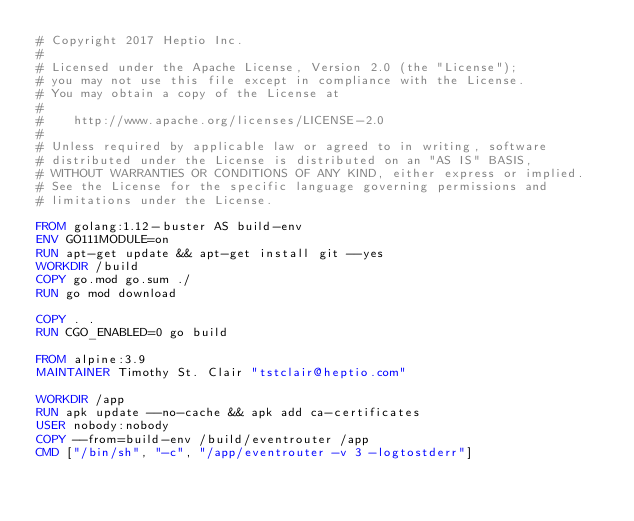<code> <loc_0><loc_0><loc_500><loc_500><_Dockerfile_># Copyright 2017 Heptio Inc.
#
# Licensed under the Apache License, Version 2.0 (the "License");
# you may not use this file except in compliance with the License.
# You may obtain a copy of the License at
#
#    http://www.apache.org/licenses/LICENSE-2.0
#
# Unless required by applicable law or agreed to in writing, software
# distributed under the License is distributed on an "AS IS" BASIS,
# WITHOUT WARRANTIES OR CONDITIONS OF ANY KIND, either express or implied.
# See the License for the specific language governing permissions and
# limitations under the License.

FROM golang:1.12-buster AS build-env
ENV GO111MODULE=on
RUN apt-get update && apt-get install git --yes
WORKDIR /build
COPY go.mod go.sum ./
RUN go mod download

COPY . .
RUN CGO_ENABLED=0 go build

FROM alpine:3.9
MAINTAINER Timothy St. Clair "tstclair@heptio.com"

WORKDIR /app
RUN apk update --no-cache && apk add ca-certificates
USER nobody:nobody
COPY --from=build-env /build/eventrouter /app
CMD ["/bin/sh", "-c", "/app/eventrouter -v 3 -logtostderr"]
</code> 